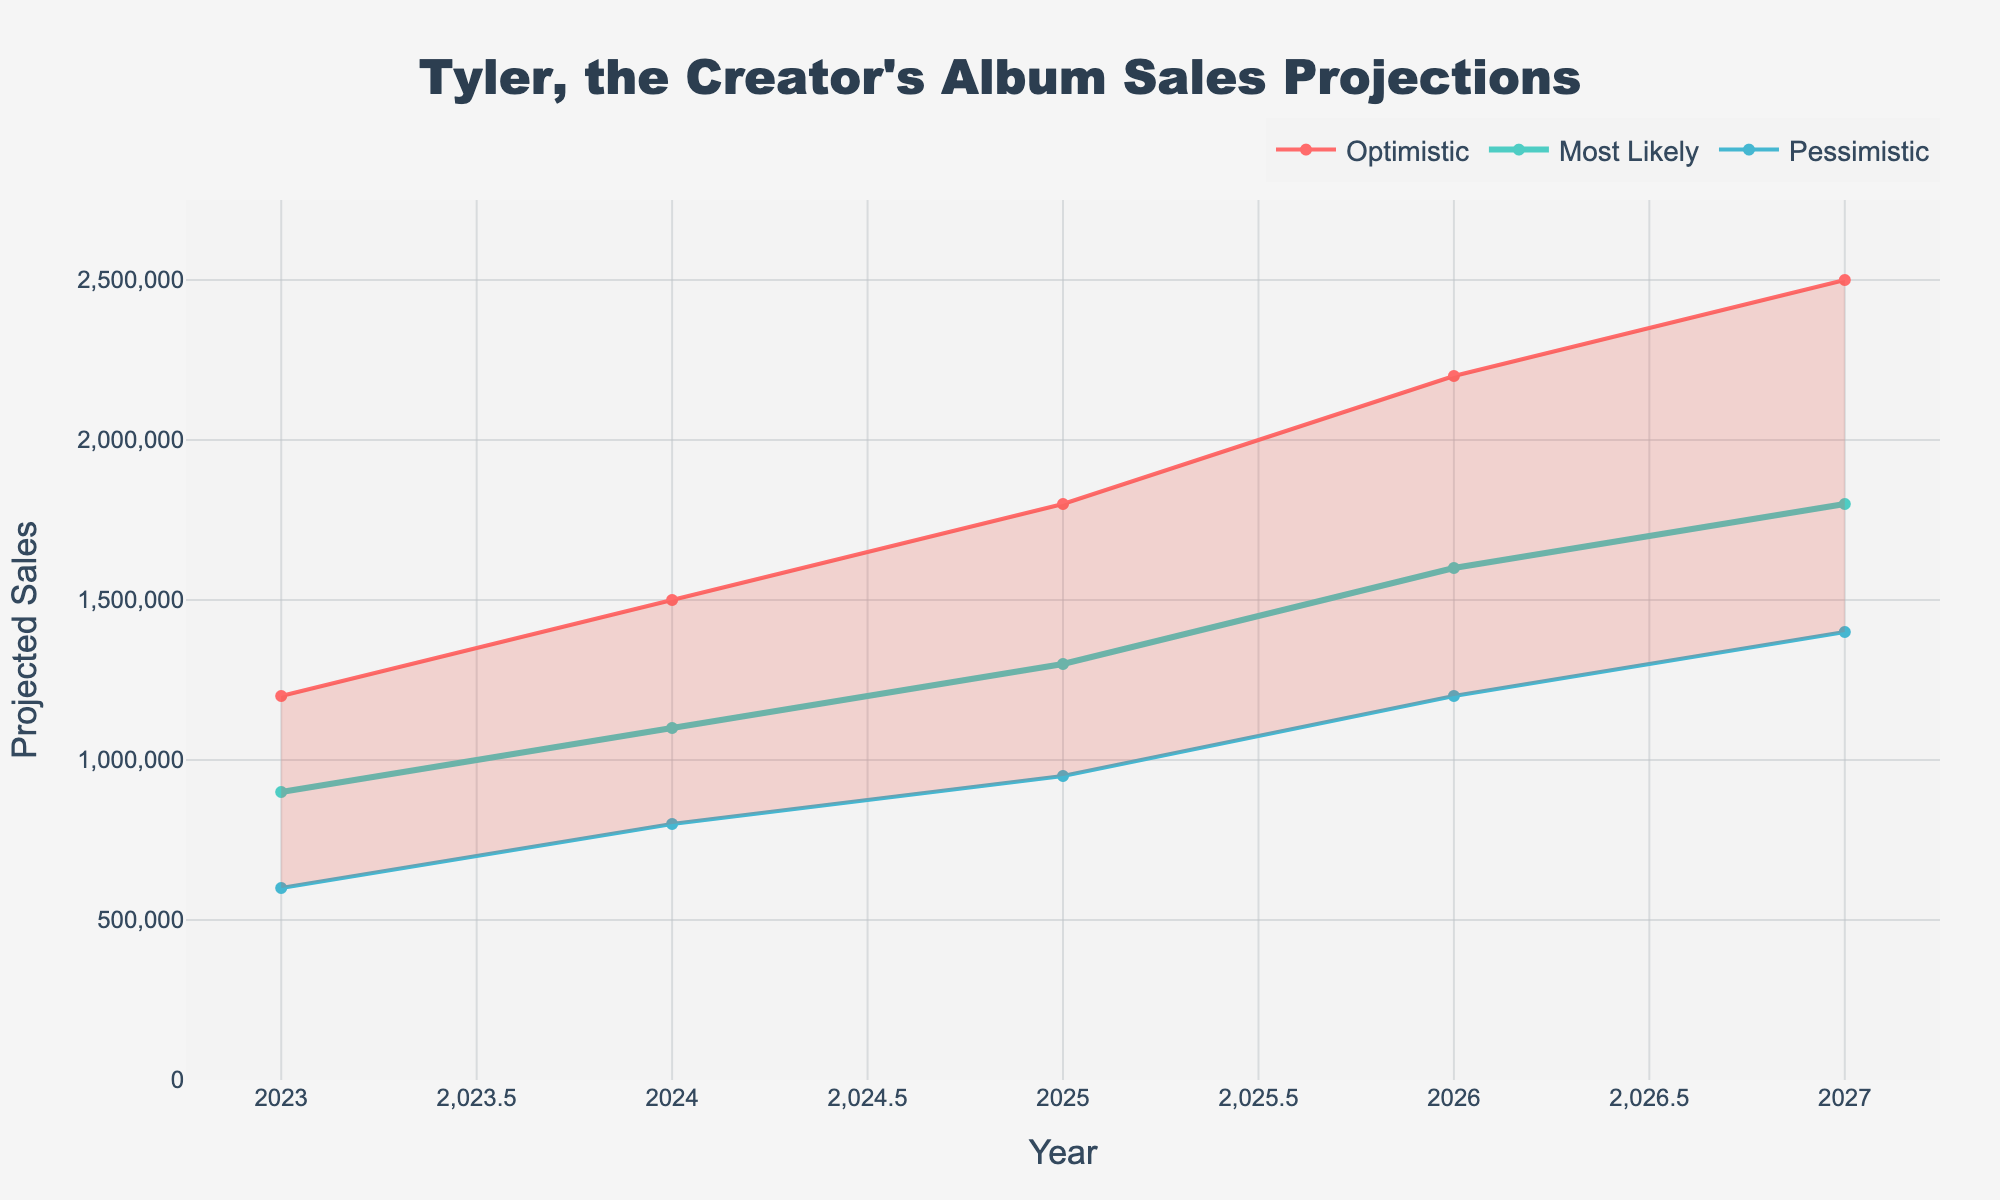What's the title of the chart? The title of the chart is usually displayed prominently at the top of the figure. In this case, it should be clear and easy to read.
Answer: Tyler, the Creator's Album Sales Projections Which scenario has the highest projected sales in 2026? To determine this, look at the lines representing each scenario for the year 2026. The optimistic line will be the highest, followed by the most likely and the pessimistic lines.
Answer: Optimistic How many years of projection are shown in the figure? Count the number of unique years listed along the x-axis, starting from 2023 and ending at 2027.
Answer: 5 What is the projected sales range for 2024? To find the range, locate the projections for both the optimistic and pessimistic scenarios for the year 2024. The range is the difference between these two values.
Answer: 700,000 What is the average of the most likely scenario's projections for the first and last years shown? Identify the most likely projections for 2023 and 2027, sum them up, and then divide by 2 to find the average.
Answer: 1,350,000 How do the optimistic and pessimistic projections compare for 2025? Look at the values for both scenarios in 2025. The optimistic projection is higher than the pessimistic one. Specifically, the optimistic is 1,800,000 and pessimistic is 950,000.
Answer: Optimistic is higher In which year do the most likely projections cross 1,500,000? Look at the most likely scenario line and determine the first year in which it crosses above 1,500,000 on the y-axis.
Answer: 2026 What is the projected growth in the optimistic scenario from 2023 to 2027? Subtract the projected sales in 2023 from the projected sales in 2027 under the optimistic scenario to find the growth.
Answer: 1,300,000 Which year shows the smallest gap between the optimistic and pessimistic projections? Compare the differences between the optimistic and pessimistic projections for each year and identify the smallest gap.
Answer: 2023 